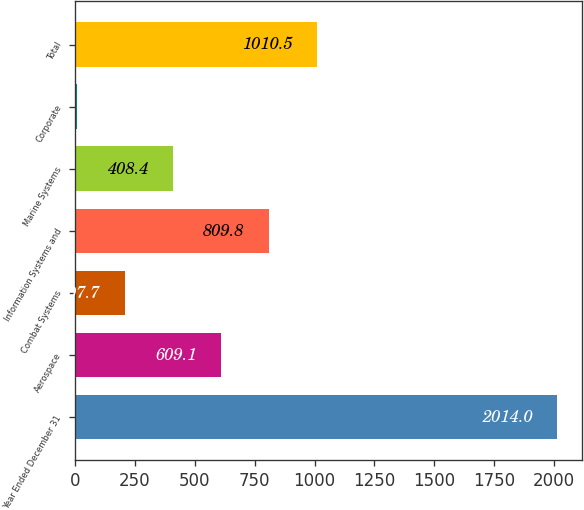<chart> <loc_0><loc_0><loc_500><loc_500><bar_chart><fcel>Year Ended December 31<fcel>Aerospace<fcel>Combat Systems<fcel>Information Systems and<fcel>Marine Systems<fcel>Corporate<fcel>Total<nl><fcel>2014<fcel>609.1<fcel>207.7<fcel>809.8<fcel>408.4<fcel>7<fcel>1010.5<nl></chart> 